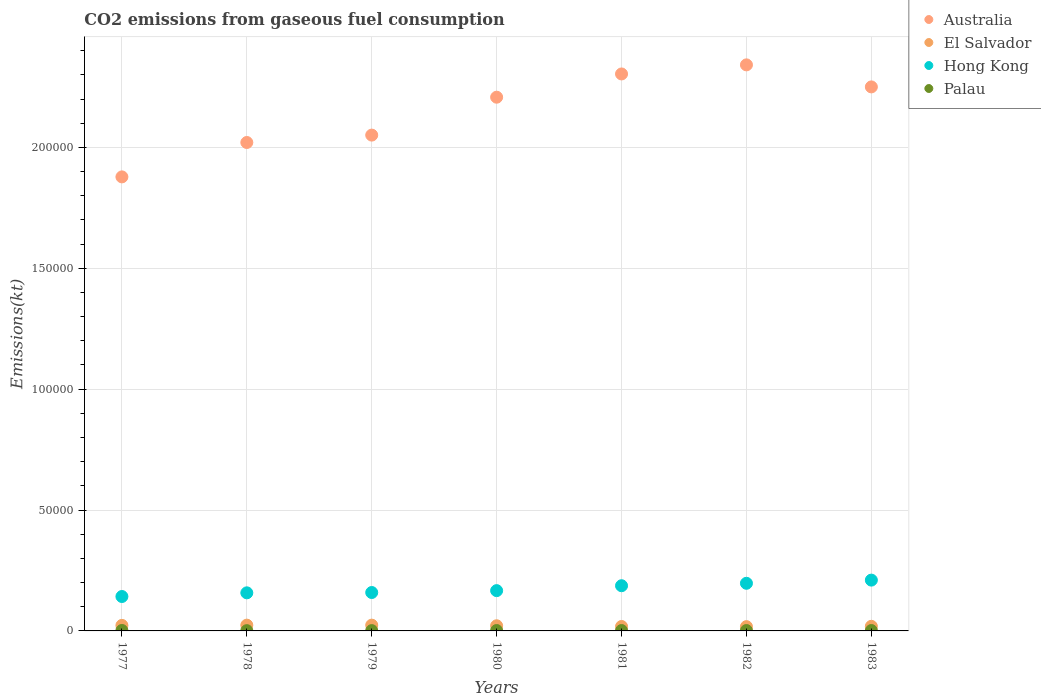How many different coloured dotlines are there?
Provide a short and direct response. 4. What is the amount of CO2 emitted in Palau in 1978?
Provide a short and direct response. 110.01. Across all years, what is the maximum amount of CO2 emitted in Hong Kong?
Make the answer very short. 2.10e+04. Across all years, what is the minimum amount of CO2 emitted in Hong Kong?
Keep it short and to the point. 1.42e+04. In which year was the amount of CO2 emitted in El Salvador maximum?
Provide a short and direct response. 1978. What is the total amount of CO2 emitted in Hong Kong in the graph?
Your answer should be compact. 1.22e+05. What is the difference between the amount of CO2 emitted in Hong Kong in 1977 and that in 1980?
Make the answer very short. -2431.22. What is the difference between the amount of CO2 emitted in El Salvador in 1981 and the amount of CO2 emitted in Palau in 1977?
Ensure brevity in your answer.  1650.15. What is the average amount of CO2 emitted in Palau per year?
Keep it short and to the point. 149.82. In the year 1979, what is the difference between the amount of CO2 emitted in Australia and amount of CO2 emitted in Palau?
Your answer should be very brief. 2.05e+05. What is the ratio of the amount of CO2 emitted in Palau in 1977 to that in 1978?
Provide a succinct answer. 1.67. Is the difference between the amount of CO2 emitted in Australia in 1977 and 1979 greater than the difference between the amount of CO2 emitted in Palau in 1977 and 1979?
Your answer should be compact. No. What is the difference between the highest and the second highest amount of CO2 emitted in Palau?
Your answer should be compact. 25.67. What is the difference between the highest and the lowest amount of CO2 emitted in El Salvador?
Give a very brief answer. 623.39. Is it the case that in every year, the sum of the amount of CO2 emitted in Palau and amount of CO2 emitted in El Salvador  is greater than the sum of amount of CO2 emitted in Hong Kong and amount of CO2 emitted in Australia?
Ensure brevity in your answer.  Yes. Is it the case that in every year, the sum of the amount of CO2 emitted in El Salvador and amount of CO2 emitted in Australia  is greater than the amount of CO2 emitted in Hong Kong?
Your answer should be compact. Yes. Is the amount of CO2 emitted in El Salvador strictly less than the amount of CO2 emitted in Australia over the years?
Your response must be concise. Yes. How many dotlines are there?
Your answer should be very brief. 4. How many years are there in the graph?
Make the answer very short. 7. Are the values on the major ticks of Y-axis written in scientific E-notation?
Ensure brevity in your answer.  No. Where does the legend appear in the graph?
Offer a terse response. Top right. What is the title of the graph?
Your answer should be compact. CO2 emissions from gaseous fuel consumption. Does "St. Kitts and Nevis" appear as one of the legend labels in the graph?
Make the answer very short. No. What is the label or title of the X-axis?
Your response must be concise. Years. What is the label or title of the Y-axis?
Offer a terse response. Emissions(kt). What is the Emissions(kt) in Australia in 1977?
Your answer should be compact. 1.88e+05. What is the Emissions(kt) in El Salvador in 1977?
Offer a very short reply. 2288.21. What is the Emissions(kt) of Hong Kong in 1977?
Your answer should be compact. 1.42e+04. What is the Emissions(kt) of Palau in 1977?
Make the answer very short. 183.35. What is the Emissions(kt) of Australia in 1978?
Your answer should be compact. 2.02e+05. What is the Emissions(kt) of El Salvador in 1978?
Offer a very short reply. 2390.88. What is the Emissions(kt) of Hong Kong in 1978?
Provide a short and direct response. 1.58e+04. What is the Emissions(kt) in Palau in 1978?
Your response must be concise. 110.01. What is the Emissions(kt) in Australia in 1979?
Ensure brevity in your answer.  2.05e+05. What is the Emissions(kt) of El Salvador in 1979?
Offer a terse response. 2390.88. What is the Emissions(kt) of Hong Kong in 1979?
Keep it short and to the point. 1.59e+04. What is the Emissions(kt) in Palau in 1979?
Provide a short and direct response. 124.68. What is the Emissions(kt) of Australia in 1980?
Your answer should be compact. 2.21e+05. What is the Emissions(kt) in El Salvador in 1980?
Offer a terse response. 2134.19. What is the Emissions(kt) in Hong Kong in 1980?
Your response must be concise. 1.67e+04. What is the Emissions(kt) of Palau in 1980?
Your answer should be compact. 157.68. What is the Emissions(kt) in Australia in 1981?
Make the answer very short. 2.30e+05. What is the Emissions(kt) of El Salvador in 1981?
Ensure brevity in your answer.  1833.5. What is the Emissions(kt) in Hong Kong in 1981?
Your response must be concise. 1.87e+04. What is the Emissions(kt) of Palau in 1981?
Make the answer very short. 157.68. What is the Emissions(kt) in Australia in 1982?
Your response must be concise. 2.34e+05. What is the Emissions(kt) of El Salvador in 1982?
Make the answer very short. 1767.49. What is the Emissions(kt) in Hong Kong in 1982?
Offer a terse response. 1.97e+04. What is the Emissions(kt) of Palau in 1982?
Provide a succinct answer. 157.68. What is the Emissions(kt) of Australia in 1983?
Provide a short and direct response. 2.25e+05. What is the Emissions(kt) in El Salvador in 1983?
Provide a succinct answer. 1903.17. What is the Emissions(kt) in Hong Kong in 1983?
Keep it short and to the point. 2.10e+04. What is the Emissions(kt) in Palau in 1983?
Offer a very short reply. 157.68. Across all years, what is the maximum Emissions(kt) in Australia?
Keep it short and to the point. 2.34e+05. Across all years, what is the maximum Emissions(kt) of El Salvador?
Provide a short and direct response. 2390.88. Across all years, what is the maximum Emissions(kt) in Hong Kong?
Offer a terse response. 2.10e+04. Across all years, what is the maximum Emissions(kt) in Palau?
Provide a succinct answer. 183.35. Across all years, what is the minimum Emissions(kt) of Australia?
Provide a short and direct response. 1.88e+05. Across all years, what is the minimum Emissions(kt) of El Salvador?
Your answer should be compact. 1767.49. Across all years, what is the minimum Emissions(kt) in Hong Kong?
Provide a succinct answer. 1.42e+04. Across all years, what is the minimum Emissions(kt) of Palau?
Your response must be concise. 110.01. What is the total Emissions(kt) in Australia in the graph?
Offer a very short reply. 1.51e+06. What is the total Emissions(kt) in El Salvador in the graph?
Offer a very short reply. 1.47e+04. What is the total Emissions(kt) in Hong Kong in the graph?
Offer a terse response. 1.22e+05. What is the total Emissions(kt) in Palau in the graph?
Provide a short and direct response. 1048.76. What is the difference between the Emissions(kt) in Australia in 1977 and that in 1978?
Ensure brevity in your answer.  -1.42e+04. What is the difference between the Emissions(kt) in El Salvador in 1977 and that in 1978?
Offer a very short reply. -102.68. What is the difference between the Emissions(kt) in Hong Kong in 1977 and that in 1978?
Your answer should be very brief. -1521.81. What is the difference between the Emissions(kt) in Palau in 1977 and that in 1978?
Give a very brief answer. 73.34. What is the difference between the Emissions(kt) in Australia in 1977 and that in 1979?
Offer a terse response. -1.73e+04. What is the difference between the Emissions(kt) of El Salvador in 1977 and that in 1979?
Provide a succinct answer. -102.68. What is the difference between the Emissions(kt) of Hong Kong in 1977 and that in 1979?
Your answer should be compact. -1653.82. What is the difference between the Emissions(kt) of Palau in 1977 and that in 1979?
Offer a very short reply. 58.67. What is the difference between the Emissions(kt) of Australia in 1977 and that in 1980?
Your response must be concise. -3.30e+04. What is the difference between the Emissions(kt) in El Salvador in 1977 and that in 1980?
Offer a terse response. 154.01. What is the difference between the Emissions(kt) of Hong Kong in 1977 and that in 1980?
Make the answer very short. -2431.22. What is the difference between the Emissions(kt) of Palau in 1977 and that in 1980?
Your answer should be very brief. 25.67. What is the difference between the Emissions(kt) of Australia in 1977 and that in 1981?
Give a very brief answer. -4.26e+04. What is the difference between the Emissions(kt) of El Salvador in 1977 and that in 1981?
Offer a terse response. 454.71. What is the difference between the Emissions(kt) of Hong Kong in 1977 and that in 1981?
Your answer should be very brief. -4459.07. What is the difference between the Emissions(kt) in Palau in 1977 and that in 1981?
Offer a very short reply. 25.67. What is the difference between the Emissions(kt) in Australia in 1977 and that in 1982?
Give a very brief answer. -4.63e+04. What is the difference between the Emissions(kt) in El Salvador in 1977 and that in 1982?
Your response must be concise. 520.71. What is the difference between the Emissions(kt) of Hong Kong in 1977 and that in 1982?
Your response must be concise. -5471.16. What is the difference between the Emissions(kt) of Palau in 1977 and that in 1982?
Offer a very short reply. 25.67. What is the difference between the Emissions(kt) of Australia in 1977 and that in 1983?
Offer a terse response. -3.72e+04. What is the difference between the Emissions(kt) of El Salvador in 1977 and that in 1983?
Offer a very short reply. 385.04. What is the difference between the Emissions(kt) of Hong Kong in 1977 and that in 1983?
Provide a succinct answer. -6783.95. What is the difference between the Emissions(kt) in Palau in 1977 and that in 1983?
Provide a short and direct response. 25.67. What is the difference between the Emissions(kt) in Australia in 1978 and that in 1979?
Ensure brevity in your answer.  -3054.61. What is the difference between the Emissions(kt) in Hong Kong in 1978 and that in 1979?
Provide a short and direct response. -132.01. What is the difference between the Emissions(kt) of Palau in 1978 and that in 1979?
Provide a short and direct response. -14.67. What is the difference between the Emissions(kt) of Australia in 1978 and that in 1980?
Offer a very short reply. -1.87e+04. What is the difference between the Emissions(kt) in El Salvador in 1978 and that in 1980?
Offer a very short reply. 256.69. What is the difference between the Emissions(kt) in Hong Kong in 1978 and that in 1980?
Make the answer very short. -909.42. What is the difference between the Emissions(kt) of Palau in 1978 and that in 1980?
Provide a short and direct response. -47.67. What is the difference between the Emissions(kt) in Australia in 1978 and that in 1981?
Offer a terse response. -2.83e+04. What is the difference between the Emissions(kt) of El Salvador in 1978 and that in 1981?
Your answer should be very brief. 557.38. What is the difference between the Emissions(kt) of Hong Kong in 1978 and that in 1981?
Your answer should be very brief. -2937.27. What is the difference between the Emissions(kt) of Palau in 1978 and that in 1981?
Keep it short and to the point. -47.67. What is the difference between the Emissions(kt) of Australia in 1978 and that in 1982?
Your answer should be very brief. -3.21e+04. What is the difference between the Emissions(kt) in El Salvador in 1978 and that in 1982?
Your response must be concise. 623.39. What is the difference between the Emissions(kt) of Hong Kong in 1978 and that in 1982?
Provide a succinct answer. -3949.36. What is the difference between the Emissions(kt) of Palau in 1978 and that in 1982?
Your answer should be compact. -47.67. What is the difference between the Emissions(kt) of Australia in 1978 and that in 1983?
Provide a succinct answer. -2.30e+04. What is the difference between the Emissions(kt) of El Salvador in 1978 and that in 1983?
Keep it short and to the point. 487.71. What is the difference between the Emissions(kt) of Hong Kong in 1978 and that in 1983?
Give a very brief answer. -5262.15. What is the difference between the Emissions(kt) in Palau in 1978 and that in 1983?
Provide a succinct answer. -47.67. What is the difference between the Emissions(kt) of Australia in 1979 and that in 1980?
Provide a succinct answer. -1.57e+04. What is the difference between the Emissions(kt) in El Salvador in 1979 and that in 1980?
Keep it short and to the point. 256.69. What is the difference between the Emissions(kt) in Hong Kong in 1979 and that in 1980?
Keep it short and to the point. -777.4. What is the difference between the Emissions(kt) in Palau in 1979 and that in 1980?
Offer a very short reply. -33. What is the difference between the Emissions(kt) of Australia in 1979 and that in 1981?
Provide a succinct answer. -2.53e+04. What is the difference between the Emissions(kt) in El Salvador in 1979 and that in 1981?
Provide a short and direct response. 557.38. What is the difference between the Emissions(kt) in Hong Kong in 1979 and that in 1981?
Offer a terse response. -2805.26. What is the difference between the Emissions(kt) in Palau in 1979 and that in 1981?
Make the answer very short. -33. What is the difference between the Emissions(kt) in Australia in 1979 and that in 1982?
Your answer should be very brief. -2.90e+04. What is the difference between the Emissions(kt) of El Salvador in 1979 and that in 1982?
Offer a very short reply. 623.39. What is the difference between the Emissions(kt) in Hong Kong in 1979 and that in 1982?
Your answer should be compact. -3817.35. What is the difference between the Emissions(kt) of Palau in 1979 and that in 1982?
Ensure brevity in your answer.  -33. What is the difference between the Emissions(kt) of Australia in 1979 and that in 1983?
Keep it short and to the point. -1.99e+04. What is the difference between the Emissions(kt) in El Salvador in 1979 and that in 1983?
Your answer should be compact. 487.71. What is the difference between the Emissions(kt) of Hong Kong in 1979 and that in 1983?
Offer a terse response. -5130.13. What is the difference between the Emissions(kt) in Palau in 1979 and that in 1983?
Your answer should be very brief. -33. What is the difference between the Emissions(kt) in Australia in 1980 and that in 1981?
Offer a terse response. -9614.87. What is the difference between the Emissions(kt) of El Salvador in 1980 and that in 1981?
Ensure brevity in your answer.  300.69. What is the difference between the Emissions(kt) in Hong Kong in 1980 and that in 1981?
Keep it short and to the point. -2027.85. What is the difference between the Emissions(kt) of Australia in 1980 and that in 1982?
Your answer should be very brief. -1.34e+04. What is the difference between the Emissions(kt) in El Salvador in 1980 and that in 1982?
Provide a short and direct response. 366.7. What is the difference between the Emissions(kt) in Hong Kong in 1980 and that in 1982?
Your answer should be compact. -3039.94. What is the difference between the Emissions(kt) in Australia in 1980 and that in 1983?
Offer a very short reply. -4257.39. What is the difference between the Emissions(kt) of El Salvador in 1980 and that in 1983?
Keep it short and to the point. 231.02. What is the difference between the Emissions(kt) in Hong Kong in 1980 and that in 1983?
Your answer should be very brief. -4352.73. What is the difference between the Emissions(kt) in Australia in 1981 and that in 1982?
Your answer should be compact. -3758.68. What is the difference between the Emissions(kt) of El Salvador in 1981 and that in 1982?
Your answer should be compact. 66.01. What is the difference between the Emissions(kt) in Hong Kong in 1981 and that in 1982?
Offer a terse response. -1012.09. What is the difference between the Emissions(kt) of Australia in 1981 and that in 1983?
Your answer should be very brief. 5357.49. What is the difference between the Emissions(kt) in El Salvador in 1981 and that in 1983?
Your answer should be very brief. -69.67. What is the difference between the Emissions(kt) of Hong Kong in 1981 and that in 1983?
Ensure brevity in your answer.  -2324.88. What is the difference between the Emissions(kt) in Palau in 1981 and that in 1983?
Your answer should be very brief. 0. What is the difference between the Emissions(kt) of Australia in 1982 and that in 1983?
Offer a very short reply. 9116.16. What is the difference between the Emissions(kt) of El Salvador in 1982 and that in 1983?
Provide a succinct answer. -135.68. What is the difference between the Emissions(kt) of Hong Kong in 1982 and that in 1983?
Your answer should be compact. -1312.79. What is the difference between the Emissions(kt) of Australia in 1977 and the Emissions(kt) of El Salvador in 1978?
Your answer should be compact. 1.85e+05. What is the difference between the Emissions(kt) of Australia in 1977 and the Emissions(kt) of Hong Kong in 1978?
Provide a short and direct response. 1.72e+05. What is the difference between the Emissions(kt) in Australia in 1977 and the Emissions(kt) in Palau in 1978?
Your answer should be very brief. 1.88e+05. What is the difference between the Emissions(kt) of El Salvador in 1977 and the Emissions(kt) of Hong Kong in 1978?
Provide a short and direct response. -1.35e+04. What is the difference between the Emissions(kt) of El Salvador in 1977 and the Emissions(kt) of Palau in 1978?
Make the answer very short. 2178.2. What is the difference between the Emissions(kt) in Hong Kong in 1977 and the Emissions(kt) in Palau in 1978?
Ensure brevity in your answer.  1.41e+04. What is the difference between the Emissions(kt) of Australia in 1977 and the Emissions(kt) of El Salvador in 1979?
Make the answer very short. 1.85e+05. What is the difference between the Emissions(kt) of Australia in 1977 and the Emissions(kt) of Hong Kong in 1979?
Give a very brief answer. 1.72e+05. What is the difference between the Emissions(kt) in Australia in 1977 and the Emissions(kt) in Palau in 1979?
Keep it short and to the point. 1.88e+05. What is the difference between the Emissions(kt) of El Salvador in 1977 and the Emissions(kt) of Hong Kong in 1979?
Your answer should be very brief. -1.36e+04. What is the difference between the Emissions(kt) of El Salvador in 1977 and the Emissions(kt) of Palau in 1979?
Ensure brevity in your answer.  2163.53. What is the difference between the Emissions(kt) in Hong Kong in 1977 and the Emissions(kt) in Palau in 1979?
Provide a short and direct response. 1.41e+04. What is the difference between the Emissions(kt) in Australia in 1977 and the Emissions(kt) in El Salvador in 1980?
Offer a very short reply. 1.86e+05. What is the difference between the Emissions(kt) in Australia in 1977 and the Emissions(kt) in Hong Kong in 1980?
Make the answer very short. 1.71e+05. What is the difference between the Emissions(kt) of Australia in 1977 and the Emissions(kt) of Palau in 1980?
Keep it short and to the point. 1.88e+05. What is the difference between the Emissions(kt) of El Salvador in 1977 and the Emissions(kt) of Hong Kong in 1980?
Your answer should be compact. -1.44e+04. What is the difference between the Emissions(kt) of El Salvador in 1977 and the Emissions(kt) of Palau in 1980?
Make the answer very short. 2130.53. What is the difference between the Emissions(kt) of Hong Kong in 1977 and the Emissions(kt) of Palau in 1980?
Provide a short and direct response. 1.41e+04. What is the difference between the Emissions(kt) of Australia in 1977 and the Emissions(kt) of El Salvador in 1981?
Make the answer very short. 1.86e+05. What is the difference between the Emissions(kt) in Australia in 1977 and the Emissions(kt) in Hong Kong in 1981?
Keep it short and to the point. 1.69e+05. What is the difference between the Emissions(kt) of Australia in 1977 and the Emissions(kt) of Palau in 1981?
Ensure brevity in your answer.  1.88e+05. What is the difference between the Emissions(kt) in El Salvador in 1977 and the Emissions(kt) in Hong Kong in 1981?
Offer a terse response. -1.64e+04. What is the difference between the Emissions(kt) of El Salvador in 1977 and the Emissions(kt) of Palau in 1981?
Your response must be concise. 2130.53. What is the difference between the Emissions(kt) in Hong Kong in 1977 and the Emissions(kt) in Palau in 1981?
Offer a very short reply. 1.41e+04. What is the difference between the Emissions(kt) in Australia in 1977 and the Emissions(kt) in El Salvador in 1982?
Your response must be concise. 1.86e+05. What is the difference between the Emissions(kt) in Australia in 1977 and the Emissions(kt) in Hong Kong in 1982?
Provide a succinct answer. 1.68e+05. What is the difference between the Emissions(kt) in Australia in 1977 and the Emissions(kt) in Palau in 1982?
Ensure brevity in your answer.  1.88e+05. What is the difference between the Emissions(kt) of El Salvador in 1977 and the Emissions(kt) of Hong Kong in 1982?
Provide a succinct answer. -1.74e+04. What is the difference between the Emissions(kt) in El Salvador in 1977 and the Emissions(kt) in Palau in 1982?
Your answer should be very brief. 2130.53. What is the difference between the Emissions(kt) of Hong Kong in 1977 and the Emissions(kt) of Palau in 1982?
Make the answer very short. 1.41e+04. What is the difference between the Emissions(kt) in Australia in 1977 and the Emissions(kt) in El Salvador in 1983?
Provide a short and direct response. 1.86e+05. What is the difference between the Emissions(kt) of Australia in 1977 and the Emissions(kt) of Hong Kong in 1983?
Provide a short and direct response. 1.67e+05. What is the difference between the Emissions(kt) of Australia in 1977 and the Emissions(kt) of Palau in 1983?
Give a very brief answer. 1.88e+05. What is the difference between the Emissions(kt) of El Salvador in 1977 and the Emissions(kt) of Hong Kong in 1983?
Give a very brief answer. -1.87e+04. What is the difference between the Emissions(kt) in El Salvador in 1977 and the Emissions(kt) in Palau in 1983?
Provide a short and direct response. 2130.53. What is the difference between the Emissions(kt) in Hong Kong in 1977 and the Emissions(kt) in Palau in 1983?
Make the answer very short. 1.41e+04. What is the difference between the Emissions(kt) in Australia in 1978 and the Emissions(kt) in El Salvador in 1979?
Keep it short and to the point. 2.00e+05. What is the difference between the Emissions(kt) in Australia in 1978 and the Emissions(kt) in Hong Kong in 1979?
Your response must be concise. 1.86e+05. What is the difference between the Emissions(kt) in Australia in 1978 and the Emissions(kt) in Palau in 1979?
Make the answer very short. 2.02e+05. What is the difference between the Emissions(kt) of El Salvador in 1978 and the Emissions(kt) of Hong Kong in 1979?
Offer a terse response. -1.35e+04. What is the difference between the Emissions(kt) of El Salvador in 1978 and the Emissions(kt) of Palau in 1979?
Provide a succinct answer. 2266.21. What is the difference between the Emissions(kt) of Hong Kong in 1978 and the Emissions(kt) of Palau in 1979?
Your answer should be compact. 1.56e+04. What is the difference between the Emissions(kt) in Australia in 1978 and the Emissions(kt) in El Salvador in 1980?
Keep it short and to the point. 2.00e+05. What is the difference between the Emissions(kt) of Australia in 1978 and the Emissions(kt) of Hong Kong in 1980?
Give a very brief answer. 1.85e+05. What is the difference between the Emissions(kt) of Australia in 1978 and the Emissions(kt) of Palau in 1980?
Make the answer very short. 2.02e+05. What is the difference between the Emissions(kt) in El Salvador in 1978 and the Emissions(kt) in Hong Kong in 1980?
Make the answer very short. -1.43e+04. What is the difference between the Emissions(kt) of El Salvador in 1978 and the Emissions(kt) of Palau in 1980?
Your response must be concise. 2233.2. What is the difference between the Emissions(kt) in Hong Kong in 1978 and the Emissions(kt) in Palau in 1980?
Your response must be concise. 1.56e+04. What is the difference between the Emissions(kt) in Australia in 1978 and the Emissions(kt) in El Salvador in 1981?
Keep it short and to the point. 2.00e+05. What is the difference between the Emissions(kt) of Australia in 1978 and the Emissions(kt) of Hong Kong in 1981?
Keep it short and to the point. 1.83e+05. What is the difference between the Emissions(kt) in Australia in 1978 and the Emissions(kt) in Palau in 1981?
Give a very brief answer. 2.02e+05. What is the difference between the Emissions(kt) of El Salvador in 1978 and the Emissions(kt) of Hong Kong in 1981?
Your answer should be very brief. -1.63e+04. What is the difference between the Emissions(kt) of El Salvador in 1978 and the Emissions(kt) of Palau in 1981?
Your answer should be very brief. 2233.2. What is the difference between the Emissions(kt) in Hong Kong in 1978 and the Emissions(kt) in Palau in 1981?
Give a very brief answer. 1.56e+04. What is the difference between the Emissions(kt) of Australia in 1978 and the Emissions(kt) of El Salvador in 1982?
Your response must be concise. 2.00e+05. What is the difference between the Emissions(kt) of Australia in 1978 and the Emissions(kt) of Hong Kong in 1982?
Offer a very short reply. 1.82e+05. What is the difference between the Emissions(kt) in Australia in 1978 and the Emissions(kt) in Palau in 1982?
Provide a succinct answer. 2.02e+05. What is the difference between the Emissions(kt) in El Salvador in 1978 and the Emissions(kt) in Hong Kong in 1982?
Offer a terse response. -1.73e+04. What is the difference between the Emissions(kt) in El Salvador in 1978 and the Emissions(kt) in Palau in 1982?
Offer a terse response. 2233.2. What is the difference between the Emissions(kt) of Hong Kong in 1978 and the Emissions(kt) of Palau in 1982?
Make the answer very short. 1.56e+04. What is the difference between the Emissions(kt) in Australia in 1978 and the Emissions(kt) in El Salvador in 1983?
Keep it short and to the point. 2.00e+05. What is the difference between the Emissions(kt) of Australia in 1978 and the Emissions(kt) of Hong Kong in 1983?
Ensure brevity in your answer.  1.81e+05. What is the difference between the Emissions(kt) in Australia in 1978 and the Emissions(kt) in Palau in 1983?
Keep it short and to the point. 2.02e+05. What is the difference between the Emissions(kt) of El Salvador in 1978 and the Emissions(kt) of Hong Kong in 1983?
Make the answer very short. -1.86e+04. What is the difference between the Emissions(kt) in El Salvador in 1978 and the Emissions(kt) in Palau in 1983?
Your answer should be compact. 2233.2. What is the difference between the Emissions(kt) in Hong Kong in 1978 and the Emissions(kt) in Palau in 1983?
Offer a terse response. 1.56e+04. What is the difference between the Emissions(kt) of Australia in 1979 and the Emissions(kt) of El Salvador in 1980?
Offer a terse response. 2.03e+05. What is the difference between the Emissions(kt) in Australia in 1979 and the Emissions(kt) in Hong Kong in 1980?
Your answer should be very brief. 1.88e+05. What is the difference between the Emissions(kt) in Australia in 1979 and the Emissions(kt) in Palau in 1980?
Your response must be concise. 2.05e+05. What is the difference between the Emissions(kt) in El Salvador in 1979 and the Emissions(kt) in Hong Kong in 1980?
Offer a terse response. -1.43e+04. What is the difference between the Emissions(kt) of El Salvador in 1979 and the Emissions(kt) of Palau in 1980?
Your response must be concise. 2233.2. What is the difference between the Emissions(kt) of Hong Kong in 1979 and the Emissions(kt) of Palau in 1980?
Provide a succinct answer. 1.57e+04. What is the difference between the Emissions(kt) in Australia in 1979 and the Emissions(kt) in El Salvador in 1981?
Offer a very short reply. 2.03e+05. What is the difference between the Emissions(kt) of Australia in 1979 and the Emissions(kt) of Hong Kong in 1981?
Your answer should be compact. 1.86e+05. What is the difference between the Emissions(kt) in Australia in 1979 and the Emissions(kt) in Palau in 1981?
Offer a very short reply. 2.05e+05. What is the difference between the Emissions(kt) of El Salvador in 1979 and the Emissions(kt) of Hong Kong in 1981?
Provide a succinct answer. -1.63e+04. What is the difference between the Emissions(kt) in El Salvador in 1979 and the Emissions(kt) in Palau in 1981?
Offer a terse response. 2233.2. What is the difference between the Emissions(kt) in Hong Kong in 1979 and the Emissions(kt) in Palau in 1981?
Provide a short and direct response. 1.57e+04. What is the difference between the Emissions(kt) in Australia in 1979 and the Emissions(kt) in El Salvador in 1982?
Ensure brevity in your answer.  2.03e+05. What is the difference between the Emissions(kt) in Australia in 1979 and the Emissions(kt) in Hong Kong in 1982?
Offer a terse response. 1.85e+05. What is the difference between the Emissions(kt) in Australia in 1979 and the Emissions(kt) in Palau in 1982?
Make the answer very short. 2.05e+05. What is the difference between the Emissions(kt) of El Salvador in 1979 and the Emissions(kt) of Hong Kong in 1982?
Your answer should be very brief. -1.73e+04. What is the difference between the Emissions(kt) of El Salvador in 1979 and the Emissions(kt) of Palau in 1982?
Provide a short and direct response. 2233.2. What is the difference between the Emissions(kt) in Hong Kong in 1979 and the Emissions(kt) in Palau in 1982?
Ensure brevity in your answer.  1.57e+04. What is the difference between the Emissions(kt) of Australia in 1979 and the Emissions(kt) of El Salvador in 1983?
Offer a very short reply. 2.03e+05. What is the difference between the Emissions(kt) of Australia in 1979 and the Emissions(kt) of Hong Kong in 1983?
Keep it short and to the point. 1.84e+05. What is the difference between the Emissions(kt) in Australia in 1979 and the Emissions(kt) in Palau in 1983?
Ensure brevity in your answer.  2.05e+05. What is the difference between the Emissions(kt) in El Salvador in 1979 and the Emissions(kt) in Hong Kong in 1983?
Provide a short and direct response. -1.86e+04. What is the difference between the Emissions(kt) of El Salvador in 1979 and the Emissions(kt) of Palau in 1983?
Provide a succinct answer. 2233.2. What is the difference between the Emissions(kt) in Hong Kong in 1979 and the Emissions(kt) in Palau in 1983?
Offer a very short reply. 1.57e+04. What is the difference between the Emissions(kt) in Australia in 1980 and the Emissions(kt) in El Salvador in 1981?
Provide a succinct answer. 2.19e+05. What is the difference between the Emissions(kt) of Australia in 1980 and the Emissions(kt) of Hong Kong in 1981?
Your answer should be very brief. 2.02e+05. What is the difference between the Emissions(kt) in Australia in 1980 and the Emissions(kt) in Palau in 1981?
Your answer should be compact. 2.21e+05. What is the difference between the Emissions(kt) of El Salvador in 1980 and the Emissions(kt) of Hong Kong in 1981?
Your answer should be very brief. -1.66e+04. What is the difference between the Emissions(kt) of El Salvador in 1980 and the Emissions(kt) of Palau in 1981?
Provide a succinct answer. 1976.51. What is the difference between the Emissions(kt) in Hong Kong in 1980 and the Emissions(kt) in Palau in 1981?
Give a very brief answer. 1.65e+04. What is the difference between the Emissions(kt) in Australia in 1980 and the Emissions(kt) in El Salvador in 1982?
Your response must be concise. 2.19e+05. What is the difference between the Emissions(kt) of Australia in 1980 and the Emissions(kt) of Hong Kong in 1982?
Provide a succinct answer. 2.01e+05. What is the difference between the Emissions(kt) in Australia in 1980 and the Emissions(kt) in Palau in 1982?
Provide a short and direct response. 2.21e+05. What is the difference between the Emissions(kt) of El Salvador in 1980 and the Emissions(kt) of Hong Kong in 1982?
Your response must be concise. -1.76e+04. What is the difference between the Emissions(kt) in El Salvador in 1980 and the Emissions(kt) in Palau in 1982?
Make the answer very short. 1976.51. What is the difference between the Emissions(kt) in Hong Kong in 1980 and the Emissions(kt) in Palau in 1982?
Provide a succinct answer. 1.65e+04. What is the difference between the Emissions(kt) in Australia in 1980 and the Emissions(kt) in El Salvador in 1983?
Provide a succinct answer. 2.19e+05. What is the difference between the Emissions(kt) of Australia in 1980 and the Emissions(kt) of Hong Kong in 1983?
Offer a terse response. 2.00e+05. What is the difference between the Emissions(kt) in Australia in 1980 and the Emissions(kt) in Palau in 1983?
Your response must be concise. 2.21e+05. What is the difference between the Emissions(kt) in El Salvador in 1980 and the Emissions(kt) in Hong Kong in 1983?
Make the answer very short. -1.89e+04. What is the difference between the Emissions(kt) of El Salvador in 1980 and the Emissions(kt) of Palau in 1983?
Your response must be concise. 1976.51. What is the difference between the Emissions(kt) in Hong Kong in 1980 and the Emissions(kt) in Palau in 1983?
Ensure brevity in your answer.  1.65e+04. What is the difference between the Emissions(kt) in Australia in 1981 and the Emissions(kt) in El Salvador in 1982?
Provide a short and direct response. 2.29e+05. What is the difference between the Emissions(kt) of Australia in 1981 and the Emissions(kt) of Hong Kong in 1982?
Provide a succinct answer. 2.11e+05. What is the difference between the Emissions(kt) in Australia in 1981 and the Emissions(kt) in Palau in 1982?
Provide a short and direct response. 2.30e+05. What is the difference between the Emissions(kt) in El Salvador in 1981 and the Emissions(kt) in Hong Kong in 1982?
Provide a short and direct response. -1.79e+04. What is the difference between the Emissions(kt) in El Salvador in 1981 and the Emissions(kt) in Palau in 1982?
Provide a short and direct response. 1675.82. What is the difference between the Emissions(kt) of Hong Kong in 1981 and the Emissions(kt) of Palau in 1982?
Make the answer very short. 1.85e+04. What is the difference between the Emissions(kt) of Australia in 1981 and the Emissions(kt) of El Salvador in 1983?
Provide a succinct answer. 2.28e+05. What is the difference between the Emissions(kt) of Australia in 1981 and the Emissions(kt) of Hong Kong in 1983?
Keep it short and to the point. 2.09e+05. What is the difference between the Emissions(kt) in Australia in 1981 and the Emissions(kt) in Palau in 1983?
Give a very brief answer. 2.30e+05. What is the difference between the Emissions(kt) in El Salvador in 1981 and the Emissions(kt) in Hong Kong in 1983?
Provide a short and direct response. -1.92e+04. What is the difference between the Emissions(kt) of El Salvador in 1981 and the Emissions(kt) of Palau in 1983?
Provide a short and direct response. 1675.82. What is the difference between the Emissions(kt) in Hong Kong in 1981 and the Emissions(kt) in Palau in 1983?
Your answer should be compact. 1.85e+04. What is the difference between the Emissions(kt) of Australia in 1982 and the Emissions(kt) of El Salvador in 1983?
Keep it short and to the point. 2.32e+05. What is the difference between the Emissions(kt) in Australia in 1982 and the Emissions(kt) in Hong Kong in 1983?
Your answer should be very brief. 2.13e+05. What is the difference between the Emissions(kt) of Australia in 1982 and the Emissions(kt) of Palau in 1983?
Give a very brief answer. 2.34e+05. What is the difference between the Emissions(kt) in El Salvador in 1982 and the Emissions(kt) in Hong Kong in 1983?
Provide a short and direct response. -1.92e+04. What is the difference between the Emissions(kt) in El Salvador in 1982 and the Emissions(kt) in Palau in 1983?
Make the answer very short. 1609.81. What is the difference between the Emissions(kt) of Hong Kong in 1982 and the Emissions(kt) of Palau in 1983?
Offer a very short reply. 1.95e+04. What is the average Emissions(kt) of Australia per year?
Provide a short and direct response. 2.15e+05. What is the average Emissions(kt) of El Salvador per year?
Make the answer very short. 2101.19. What is the average Emissions(kt) of Hong Kong per year?
Keep it short and to the point. 1.74e+04. What is the average Emissions(kt) of Palau per year?
Offer a very short reply. 149.82. In the year 1977, what is the difference between the Emissions(kt) of Australia and Emissions(kt) of El Salvador?
Keep it short and to the point. 1.85e+05. In the year 1977, what is the difference between the Emissions(kt) in Australia and Emissions(kt) in Hong Kong?
Offer a very short reply. 1.74e+05. In the year 1977, what is the difference between the Emissions(kt) of Australia and Emissions(kt) of Palau?
Make the answer very short. 1.88e+05. In the year 1977, what is the difference between the Emissions(kt) of El Salvador and Emissions(kt) of Hong Kong?
Provide a short and direct response. -1.19e+04. In the year 1977, what is the difference between the Emissions(kt) of El Salvador and Emissions(kt) of Palau?
Your answer should be compact. 2104.86. In the year 1977, what is the difference between the Emissions(kt) of Hong Kong and Emissions(kt) of Palau?
Provide a succinct answer. 1.40e+04. In the year 1978, what is the difference between the Emissions(kt) in Australia and Emissions(kt) in El Salvador?
Give a very brief answer. 2.00e+05. In the year 1978, what is the difference between the Emissions(kt) in Australia and Emissions(kt) in Hong Kong?
Your answer should be very brief. 1.86e+05. In the year 1978, what is the difference between the Emissions(kt) in Australia and Emissions(kt) in Palau?
Offer a terse response. 2.02e+05. In the year 1978, what is the difference between the Emissions(kt) in El Salvador and Emissions(kt) in Hong Kong?
Offer a very short reply. -1.34e+04. In the year 1978, what is the difference between the Emissions(kt) in El Salvador and Emissions(kt) in Palau?
Provide a short and direct response. 2280.87. In the year 1978, what is the difference between the Emissions(kt) of Hong Kong and Emissions(kt) of Palau?
Your response must be concise. 1.56e+04. In the year 1979, what is the difference between the Emissions(kt) in Australia and Emissions(kt) in El Salvador?
Provide a succinct answer. 2.03e+05. In the year 1979, what is the difference between the Emissions(kt) in Australia and Emissions(kt) in Hong Kong?
Offer a very short reply. 1.89e+05. In the year 1979, what is the difference between the Emissions(kt) of Australia and Emissions(kt) of Palau?
Your answer should be compact. 2.05e+05. In the year 1979, what is the difference between the Emissions(kt) in El Salvador and Emissions(kt) in Hong Kong?
Provide a succinct answer. -1.35e+04. In the year 1979, what is the difference between the Emissions(kt) of El Salvador and Emissions(kt) of Palau?
Make the answer very short. 2266.21. In the year 1979, what is the difference between the Emissions(kt) of Hong Kong and Emissions(kt) of Palau?
Offer a terse response. 1.58e+04. In the year 1980, what is the difference between the Emissions(kt) of Australia and Emissions(kt) of El Salvador?
Give a very brief answer. 2.19e+05. In the year 1980, what is the difference between the Emissions(kt) in Australia and Emissions(kt) in Hong Kong?
Give a very brief answer. 2.04e+05. In the year 1980, what is the difference between the Emissions(kt) of Australia and Emissions(kt) of Palau?
Keep it short and to the point. 2.21e+05. In the year 1980, what is the difference between the Emissions(kt) in El Salvador and Emissions(kt) in Hong Kong?
Keep it short and to the point. -1.45e+04. In the year 1980, what is the difference between the Emissions(kt) of El Salvador and Emissions(kt) of Palau?
Offer a very short reply. 1976.51. In the year 1980, what is the difference between the Emissions(kt) of Hong Kong and Emissions(kt) of Palau?
Give a very brief answer. 1.65e+04. In the year 1981, what is the difference between the Emissions(kt) of Australia and Emissions(kt) of El Salvador?
Keep it short and to the point. 2.29e+05. In the year 1981, what is the difference between the Emissions(kt) of Australia and Emissions(kt) of Hong Kong?
Offer a terse response. 2.12e+05. In the year 1981, what is the difference between the Emissions(kt) in Australia and Emissions(kt) in Palau?
Keep it short and to the point. 2.30e+05. In the year 1981, what is the difference between the Emissions(kt) in El Salvador and Emissions(kt) in Hong Kong?
Provide a short and direct response. -1.69e+04. In the year 1981, what is the difference between the Emissions(kt) in El Salvador and Emissions(kt) in Palau?
Make the answer very short. 1675.82. In the year 1981, what is the difference between the Emissions(kt) of Hong Kong and Emissions(kt) of Palau?
Make the answer very short. 1.85e+04. In the year 1982, what is the difference between the Emissions(kt) of Australia and Emissions(kt) of El Salvador?
Offer a very short reply. 2.32e+05. In the year 1982, what is the difference between the Emissions(kt) in Australia and Emissions(kt) in Hong Kong?
Your answer should be compact. 2.14e+05. In the year 1982, what is the difference between the Emissions(kt) of Australia and Emissions(kt) of Palau?
Ensure brevity in your answer.  2.34e+05. In the year 1982, what is the difference between the Emissions(kt) of El Salvador and Emissions(kt) of Hong Kong?
Offer a very short reply. -1.79e+04. In the year 1982, what is the difference between the Emissions(kt) in El Salvador and Emissions(kt) in Palau?
Your response must be concise. 1609.81. In the year 1982, what is the difference between the Emissions(kt) in Hong Kong and Emissions(kt) in Palau?
Offer a terse response. 1.95e+04. In the year 1983, what is the difference between the Emissions(kt) of Australia and Emissions(kt) of El Salvador?
Keep it short and to the point. 2.23e+05. In the year 1983, what is the difference between the Emissions(kt) in Australia and Emissions(kt) in Hong Kong?
Offer a terse response. 2.04e+05. In the year 1983, what is the difference between the Emissions(kt) of Australia and Emissions(kt) of Palau?
Ensure brevity in your answer.  2.25e+05. In the year 1983, what is the difference between the Emissions(kt) in El Salvador and Emissions(kt) in Hong Kong?
Make the answer very short. -1.91e+04. In the year 1983, what is the difference between the Emissions(kt) in El Salvador and Emissions(kt) in Palau?
Offer a terse response. 1745.49. In the year 1983, what is the difference between the Emissions(kt) of Hong Kong and Emissions(kt) of Palau?
Provide a short and direct response. 2.09e+04. What is the ratio of the Emissions(kt) of Australia in 1977 to that in 1978?
Ensure brevity in your answer.  0.93. What is the ratio of the Emissions(kt) of El Salvador in 1977 to that in 1978?
Ensure brevity in your answer.  0.96. What is the ratio of the Emissions(kt) of Hong Kong in 1977 to that in 1978?
Provide a succinct answer. 0.9. What is the ratio of the Emissions(kt) of Australia in 1977 to that in 1979?
Your answer should be compact. 0.92. What is the ratio of the Emissions(kt) of El Salvador in 1977 to that in 1979?
Your response must be concise. 0.96. What is the ratio of the Emissions(kt) of Hong Kong in 1977 to that in 1979?
Your response must be concise. 0.9. What is the ratio of the Emissions(kt) of Palau in 1977 to that in 1979?
Give a very brief answer. 1.47. What is the ratio of the Emissions(kt) in Australia in 1977 to that in 1980?
Keep it short and to the point. 0.85. What is the ratio of the Emissions(kt) in El Salvador in 1977 to that in 1980?
Provide a short and direct response. 1.07. What is the ratio of the Emissions(kt) in Hong Kong in 1977 to that in 1980?
Provide a short and direct response. 0.85. What is the ratio of the Emissions(kt) in Palau in 1977 to that in 1980?
Provide a succinct answer. 1.16. What is the ratio of the Emissions(kt) in Australia in 1977 to that in 1981?
Your response must be concise. 0.82. What is the ratio of the Emissions(kt) of El Salvador in 1977 to that in 1981?
Provide a short and direct response. 1.25. What is the ratio of the Emissions(kt) in Hong Kong in 1977 to that in 1981?
Offer a terse response. 0.76. What is the ratio of the Emissions(kt) of Palau in 1977 to that in 1981?
Your response must be concise. 1.16. What is the ratio of the Emissions(kt) in Australia in 1977 to that in 1982?
Your response must be concise. 0.8. What is the ratio of the Emissions(kt) of El Salvador in 1977 to that in 1982?
Keep it short and to the point. 1.29. What is the ratio of the Emissions(kt) of Hong Kong in 1977 to that in 1982?
Ensure brevity in your answer.  0.72. What is the ratio of the Emissions(kt) of Palau in 1977 to that in 1982?
Provide a short and direct response. 1.16. What is the ratio of the Emissions(kt) of Australia in 1977 to that in 1983?
Ensure brevity in your answer.  0.83. What is the ratio of the Emissions(kt) in El Salvador in 1977 to that in 1983?
Provide a succinct answer. 1.2. What is the ratio of the Emissions(kt) in Hong Kong in 1977 to that in 1983?
Provide a short and direct response. 0.68. What is the ratio of the Emissions(kt) in Palau in 1977 to that in 1983?
Give a very brief answer. 1.16. What is the ratio of the Emissions(kt) of Australia in 1978 to that in 1979?
Make the answer very short. 0.99. What is the ratio of the Emissions(kt) in Palau in 1978 to that in 1979?
Offer a very short reply. 0.88. What is the ratio of the Emissions(kt) in Australia in 1978 to that in 1980?
Give a very brief answer. 0.92. What is the ratio of the Emissions(kt) of El Salvador in 1978 to that in 1980?
Give a very brief answer. 1.12. What is the ratio of the Emissions(kt) of Hong Kong in 1978 to that in 1980?
Give a very brief answer. 0.95. What is the ratio of the Emissions(kt) of Palau in 1978 to that in 1980?
Your answer should be compact. 0.7. What is the ratio of the Emissions(kt) in Australia in 1978 to that in 1981?
Your response must be concise. 0.88. What is the ratio of the Emissions(kt) of El Salvador in 1978 to that in 1981?
Provide a succinct answer. 1.3. What is the ratio of the Emissions(kt) in Hong Kong in 1978 to that in 1981?
Make the answer very short. 0.84. What is the ratio of the Emissions(kt) of Palau in 1978 to that in 1981?
Provide a succinct answer. 0.7. What is the ratio of the Emissions(kt) of Australia in 1978 to that in 1982?
Make the answer very short. 0.86. What is the ratio of the Emissions(kt) of El Salvador in 1978 to that in 1982?
Ensure brevity in your answer.  1.35. What is the ratio of the Emissions(kt) in Hong Kong in 1978 to that in 1982?
Your answer should be compact. 0.8. What is the ratio of the Emissions(kt) in Palau in 1978 to that in 1982?
Offer a very short reply. 0.7. What is the ratio of the Emissions(kt) of Australia in 1978 to that in 1983?
Your response must be concise. 0.9. What is the ratio of the Emissions(kt) of El Salvador in 1978 to that in 1983?
Provide a short and direct response. 1.26. What is the ratio of the Emissions(kt) of Hong Kong in 1978 to that in 1983?
Your answer should be compact. 0.75. What is the ratio of the Emissions(kt) in Palau in 1978 to that in 1983?
Provide a succinct answer. 0.7. What is the ratio of the Emissions(kt) of Australia in 1979 to that in 1980?
Offer a very short reply. 0.93. What is the ratio of the Emissions(kt) in El Salvador in 1979 to that in 1980?
Make the answer very short. 1.12. What is the ratio of the Emissions(kt) in Hong Kong in 1979 to that in 1980?
Keep it short and to the point. 0.95. What is the ratio of the Emissions(kt) in Palau in 1979 to that in 1980?
Your answer should be very brief. 0.79. What is the ratio of the Emissions(kt) in Australia in 1979 to that in 1981?
Offer a terse response. 0.89. What is the ratio of the Emissions(kt) in El Salvador in 1979 to that in 1981?
Your answer should be compact. 1.3. What is the ratio of the Emissions(kt) in Hong Kong in 1979 to that in 1981?
Make the answer very short. 0.85. What is the ratio of the Emissions(kt) of Palau in 1979 to that in 1981?
Give a very brief answer. 0.79. What is the ratio of the Emissions(kt) in Australia in 1979 to that in 1982?
Give a very brief answer. 0.88. What is the ratio of the Emissions(kt) of El Salvador in 1979 to that in 1982?
Your answer should be very brief. 1.35. What is the ratio of the Emissions(kt) of Hong Kong in 1979 to that in 1982?
Provide a short and direct response. 0.81. What is the ratio of the Emissions(kt) in Palau in 1979 to that in 1982?
Make the answer very short. 0.79. What is the ratio of the Emissions(kt) of Australia in 1979 to that in 1983?
Your answer should be very brief. 0.91. What is the ratio of the Emissions(kt) of El Salvador in 1979 to that in 1983?
Offer a terse response. 1.26. What is the ratio of the Emissions(kt) in Hong Kong in 1979 to that in 1983?
Keep it short and to the point. 0.76. What is the ratio of the Emissions(kt) of Palau in 1979 to that in 1983?
Your answer should be very brief. 0.79. What is the ratio of the Emissions(kt) in El Salvador in 1980 to that in 1981?
Offer a terse response. 1.16. What is the ratio of the Emissions(kt) of Hong Kong in 1980 to that in 1981?
Provide a short and direct response. 0.89. What is the ratio of the Emissions(kt) of Palau in 1980 to that in 1981?
Your answer should be very brief. 1. What is the ratio of the Emissions(kt) of Australia in 1980 to that in 1982?
Your answer should be compact. 0.94. What is the ratio of the Emissions(kt) of El Salvador in 1980 to that in 1982?
Your response must be concise. 1.21. What is the ratio of the Emissions(kt) of Hong Kong in 1980 to that in 1982?
Offer a terse response. 0.85. What is the ratio of the Emissions(kt) of Palau in 1980 to that in 1982?
Ensure brevity in your answer.  1. What is the ratio of the Emissions(kt) of Australia in 1980 to that in 1983?
Your response must be concise. 0.98. What is the ratio of the Emissions(kt) of El Salvador in 1980 to that in 1983?
Offer a very short reply. 1.12. What is the ratio of the Emissions(kt) of Hong Kong in 1980 to that in 1983?
Keep it short and to the point. 0.79. What is the ratio of the Emissions(kt) of Australia in 1981 to that in 1982?
Provide a short and direct response. 0.98. What is the ratio of the Emissions(kt) in El Salvador in 1981 to that in 1982?
Ensure brevity in your answer.  1.04. What is the ratio of the Emissions(kt) of Hong Kong in 1981 to that in 1982?
Provide a succinct answer. 0.95. What is the ratio of the Emissions(kt) in Palau in 1981 to that in 1982?
Give a very brief answer. 1. What is the ratio of the Emissions(kt) in Australia in 1981 to that in 1983?
Offer a very short reply. 1.02. What is the ratio of the Emissions(kt) of El Salvador in 1981 to that in 1983?
Give a very brief answer. 0.96. What is the ratio of the Emissions(kt) of Hong Kong in 1981 to that in 1983?
Your answer should be compact. 0.89. What is the ratio of the Emissions(kt) in Palau in 1981 to that in 1983?
Provide a short and direct response. 1. What is the ratio of the Emissions(kt) in Australia in 1982 to that in 1983?
Ensure brevity in your answer.  1.04. What is the ratio of the Emissions(kt) of El Salvador in 1982 to that in 1983?
Offer a very short reply. 0.93. What is the difference between the highest and the second highest Emissions(kt) of Australia?
Offer a terse response. 3758.68. What is the difference between the highest and the second highest Emissions(kt) in Hong Kong?
Give a very brief answer. 1312.79. What is the difference between the highest and the second highest Emissions(kt) in Palau?
Provide a short and direct response. 25.67. What is the difference between the highest and the lowest Emissions(kt) of Australia?
Your answer should be compact. 4.63e+04. What is the difference between the highest and the lowest Emissions(kt) of El Salvador?
Make the answer very short. 623.39. What is the difference between the highest and the lowest Emissions(kt) in Hong Kong?
Your response must be concise. 6783.95. What is the difference between the highest and the lowest Emissions(kt) of Palau?
Give a very brief answer. 73.34. 